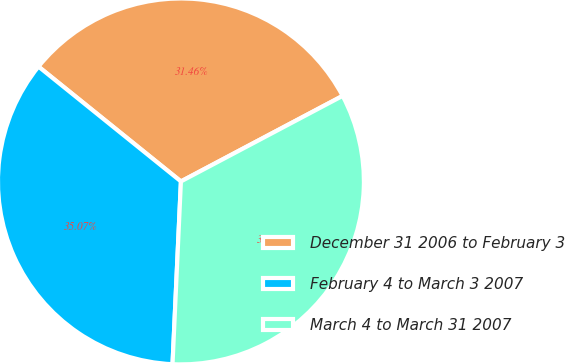Convert chart. <chart><loc_0><loc_0><loc_500><loc_500><pie_chart><fcel>December 31 2006 to February 3<fcel>February 4 to March 3 2007<fcel>March 4 to March 31 2007<nl><fcel>31.46%<fcel>35.07%<fcel>33.48%<nl></chart> 